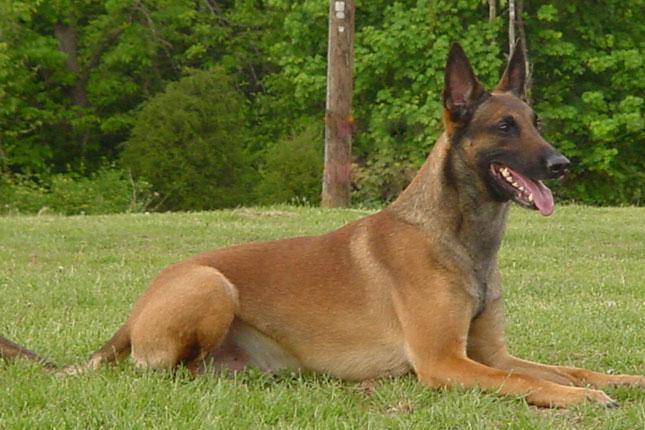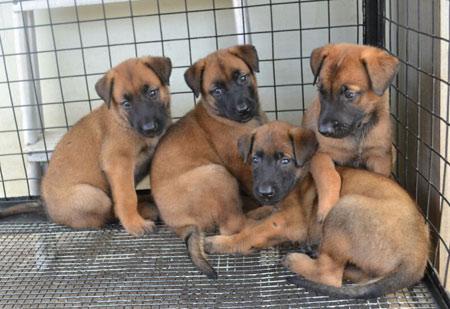The first image is the image on the left, the second image is the image on the right. Considering the images on both sides, is "There are at most five dogs." valid? Answer yes or no. Yes. 